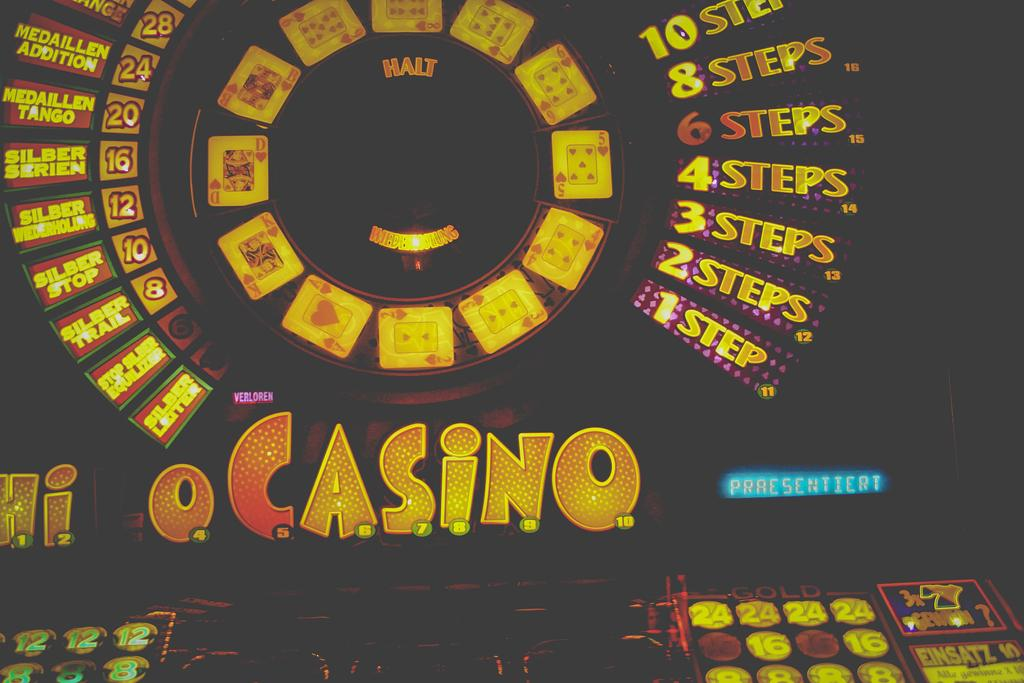Provide a one-sentence caption for the provided image. casino game or some sort of machine for gambling. 